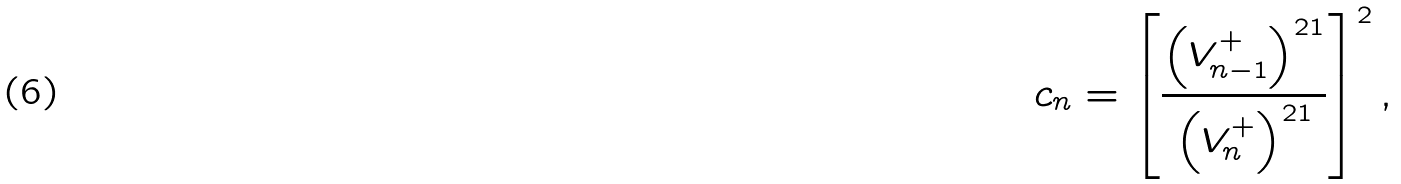<formula> <loc_0><loc_0><loc_500><loc_500>c _ { n } = \left [ \frac { \left ( V _ { n - 1 } ^ { + } \right ) ^ { 2 1 } } { \left ( V _ { n } ^ { + } \right ) ^ { 2 1 } } \right ] ^ { 2 } ,</formula> 